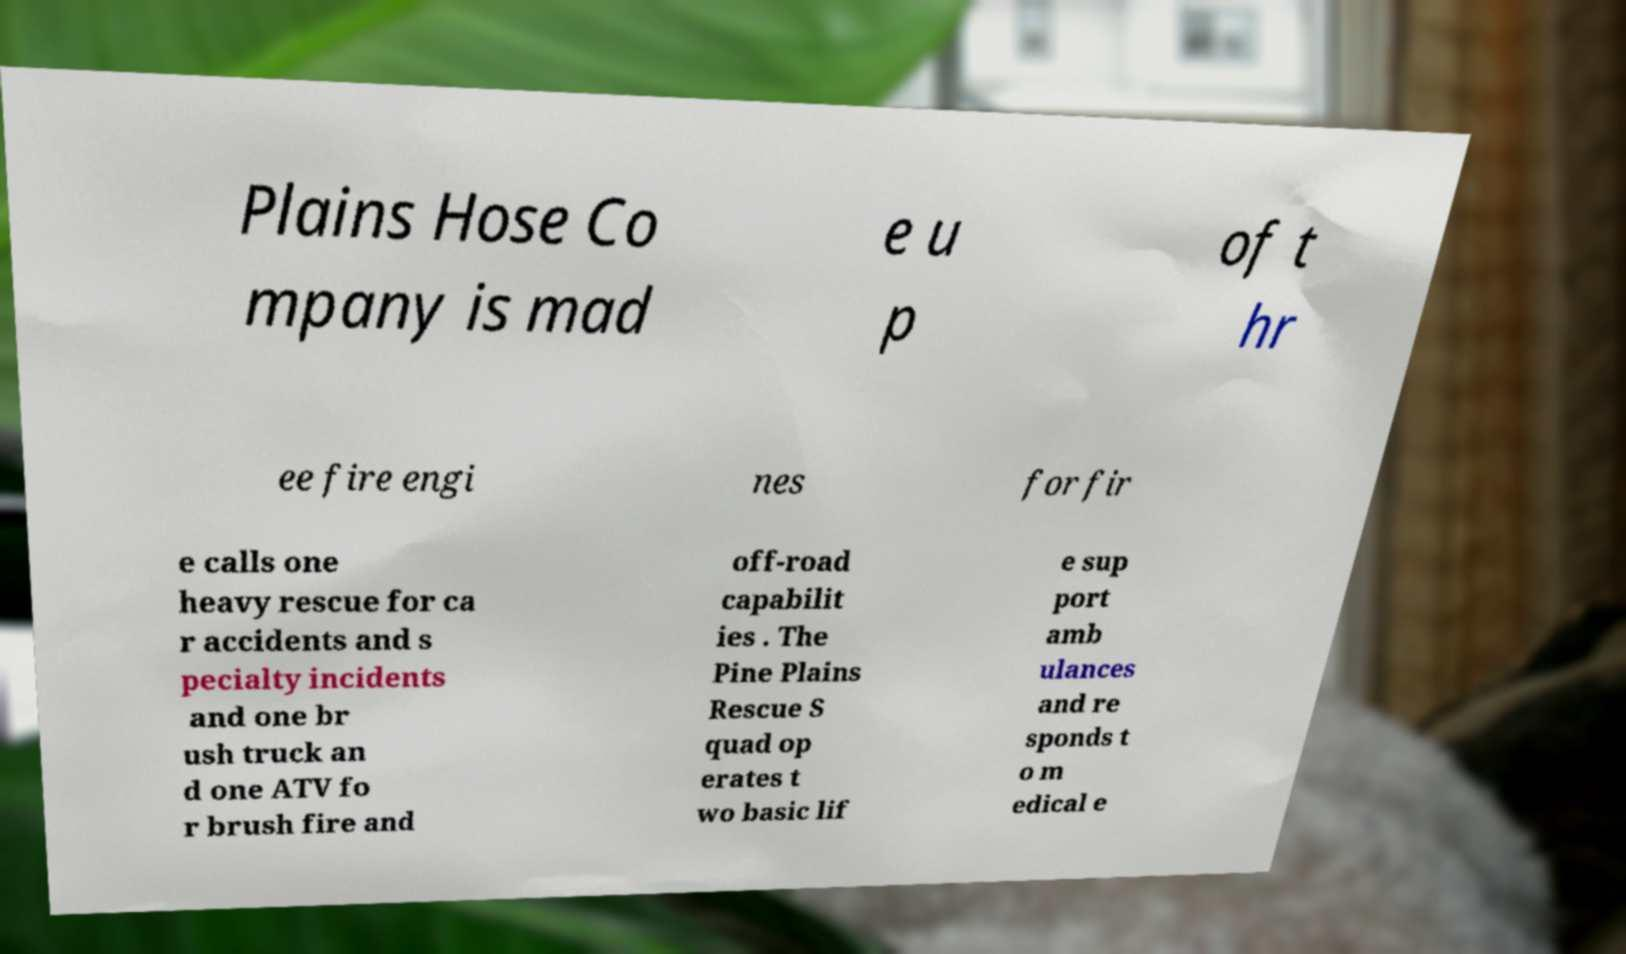Could you assist in decoding the text presented in this image and type it out clearly? Plains Hose Co mpany is mad e u p of t hr ee fire engi nes for fir e calls one heavy rescue for ca r accidents and s pecialty incidents and one br ush truck an d one ATV fo r brush fire and off-road capabilit ies . The Pine Plains Rescue S quad op erates t wo basic lif e sup port amb ulances and re sponds t o m edical e 